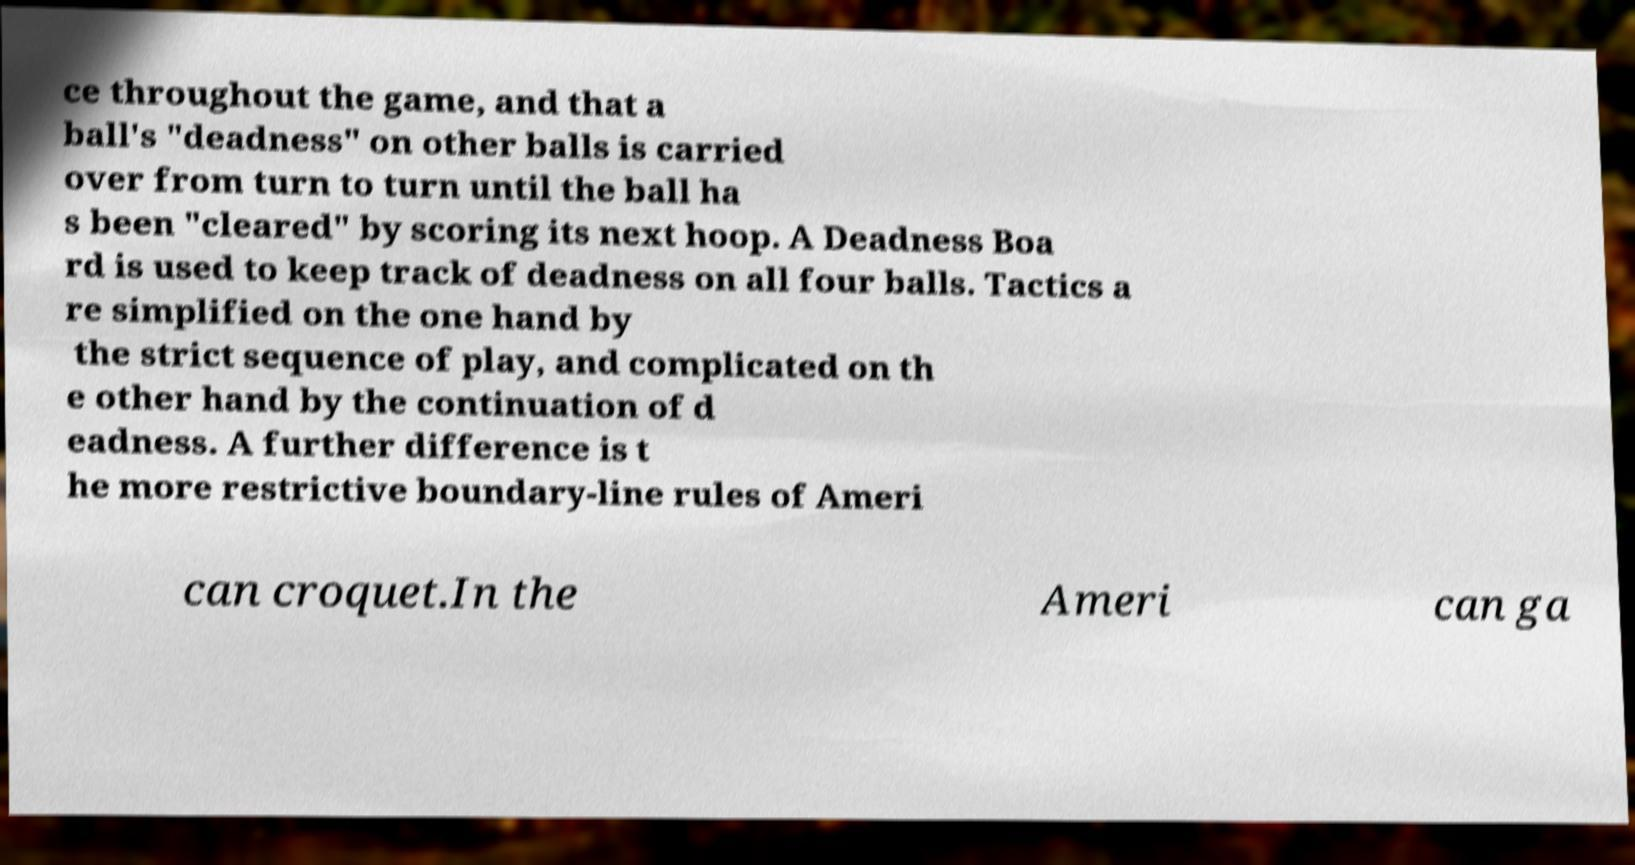Could you assist in decoding the text presented in this image and type it out clearly? ce throughout the game, and that a ball's "deadness" on other balls is carried over from turn to turn until the ball ha s been "cleared" by scoring its next hoop. A Deadness Boa rd is used to keep track of deadness on all four balls. Tactics a re simplified on the one hand by the strict sequence of play, and complicated on th e other hand by the continuation of d eadness. A further difference is t he more restrictive boundary-line rules of Ameri can croquet.In the Ameri can ga 